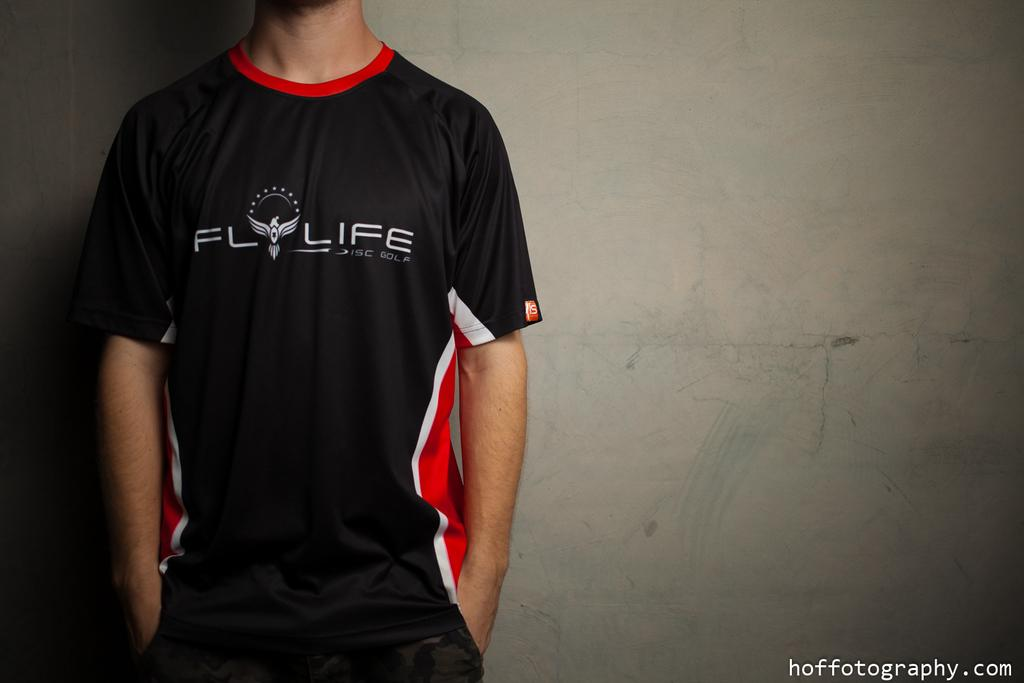Provide a one-sentence caption for the provided image. A man stands against a wall wearing his disc golf uniform. 